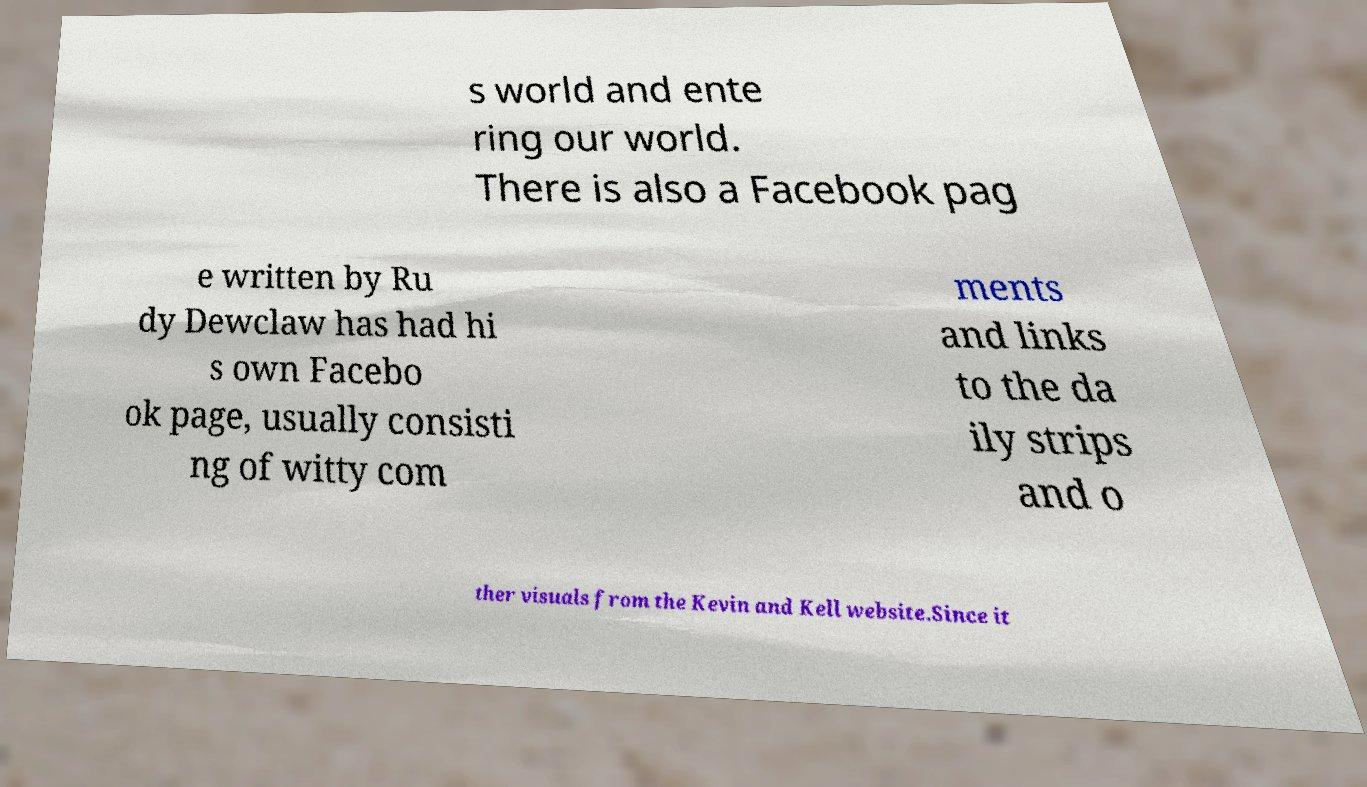What messages or text are displayed in this image? I need them in a readable, typed format. s world and ente ring our world. There is also a Facebook pag e written by Ru dy Dewclaw has had hi s own Facebo ok page, usually consisti ng of witty com ments and links to the da ily strips and o ther visuals from the Kevin and Kell website.Since it 